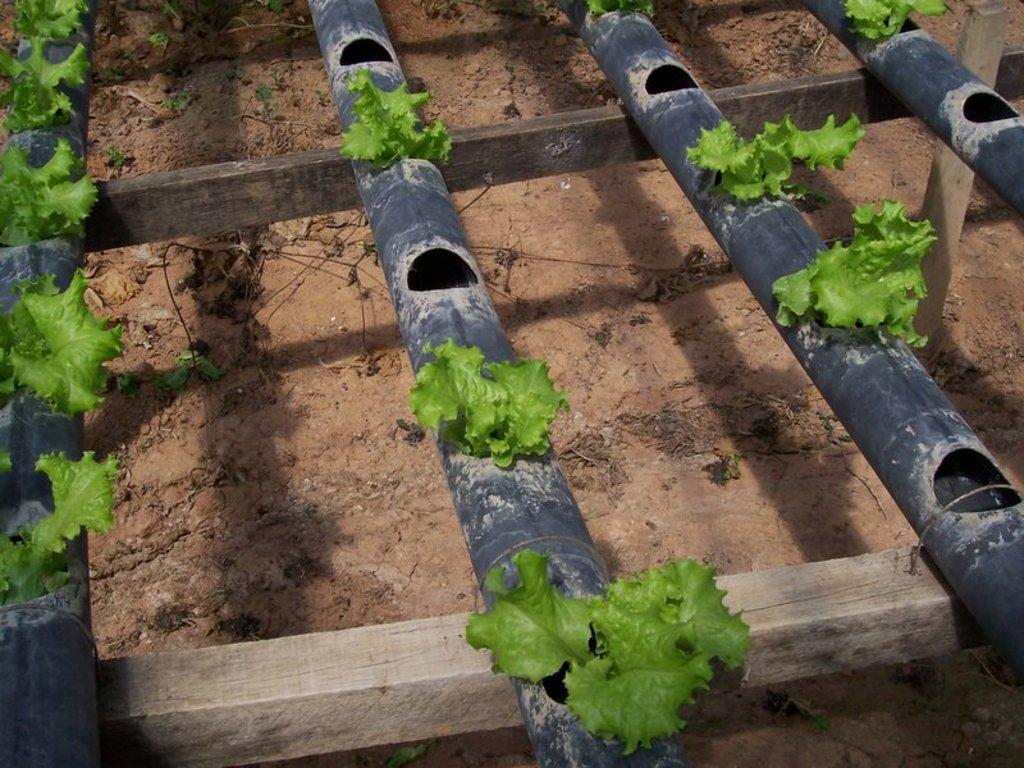What can be seen running through the image? There are pipes in the image. What is growing inside the pipes? There are plants inside the pipes. How are the plants being supported by the pipes? There are holes in the pipes that allow the plants to grow through them. What type of structure is present in the image? There is a wooden frame in the image. What material is present on the floor in the image? Soil is present on the floor. Can you see the receipt for the dress in the image? There is no receipt or dress present in the image. What type of chalk is being used to draw on the wooden frame? There is no chalk or drawing activity present in the image. 